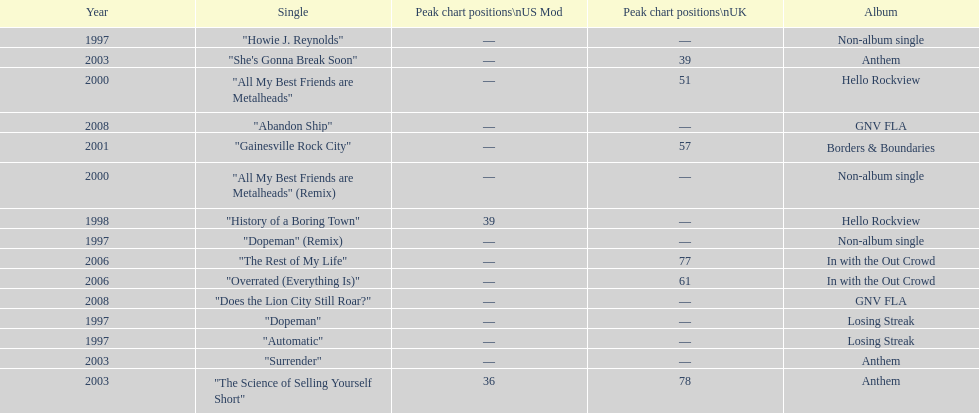What was the average chart position of their singles in the uk? 60.5. 